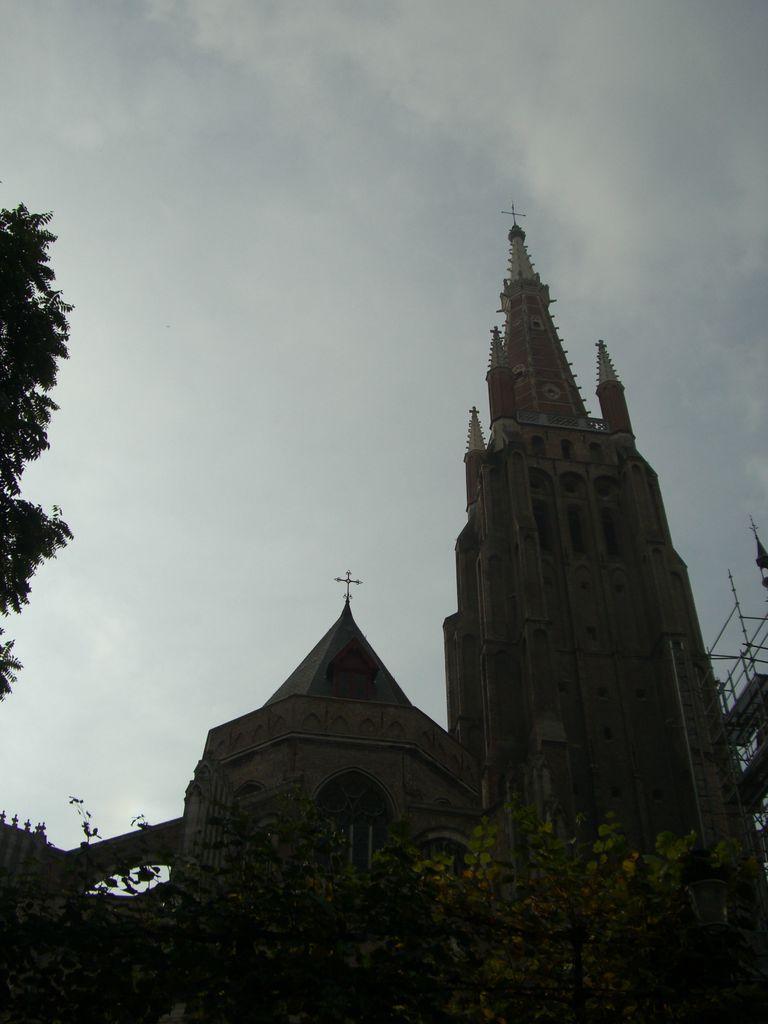Could you give a brief overview of what you see in this image? In the picture there are two churches and around the churches there are few trees. 